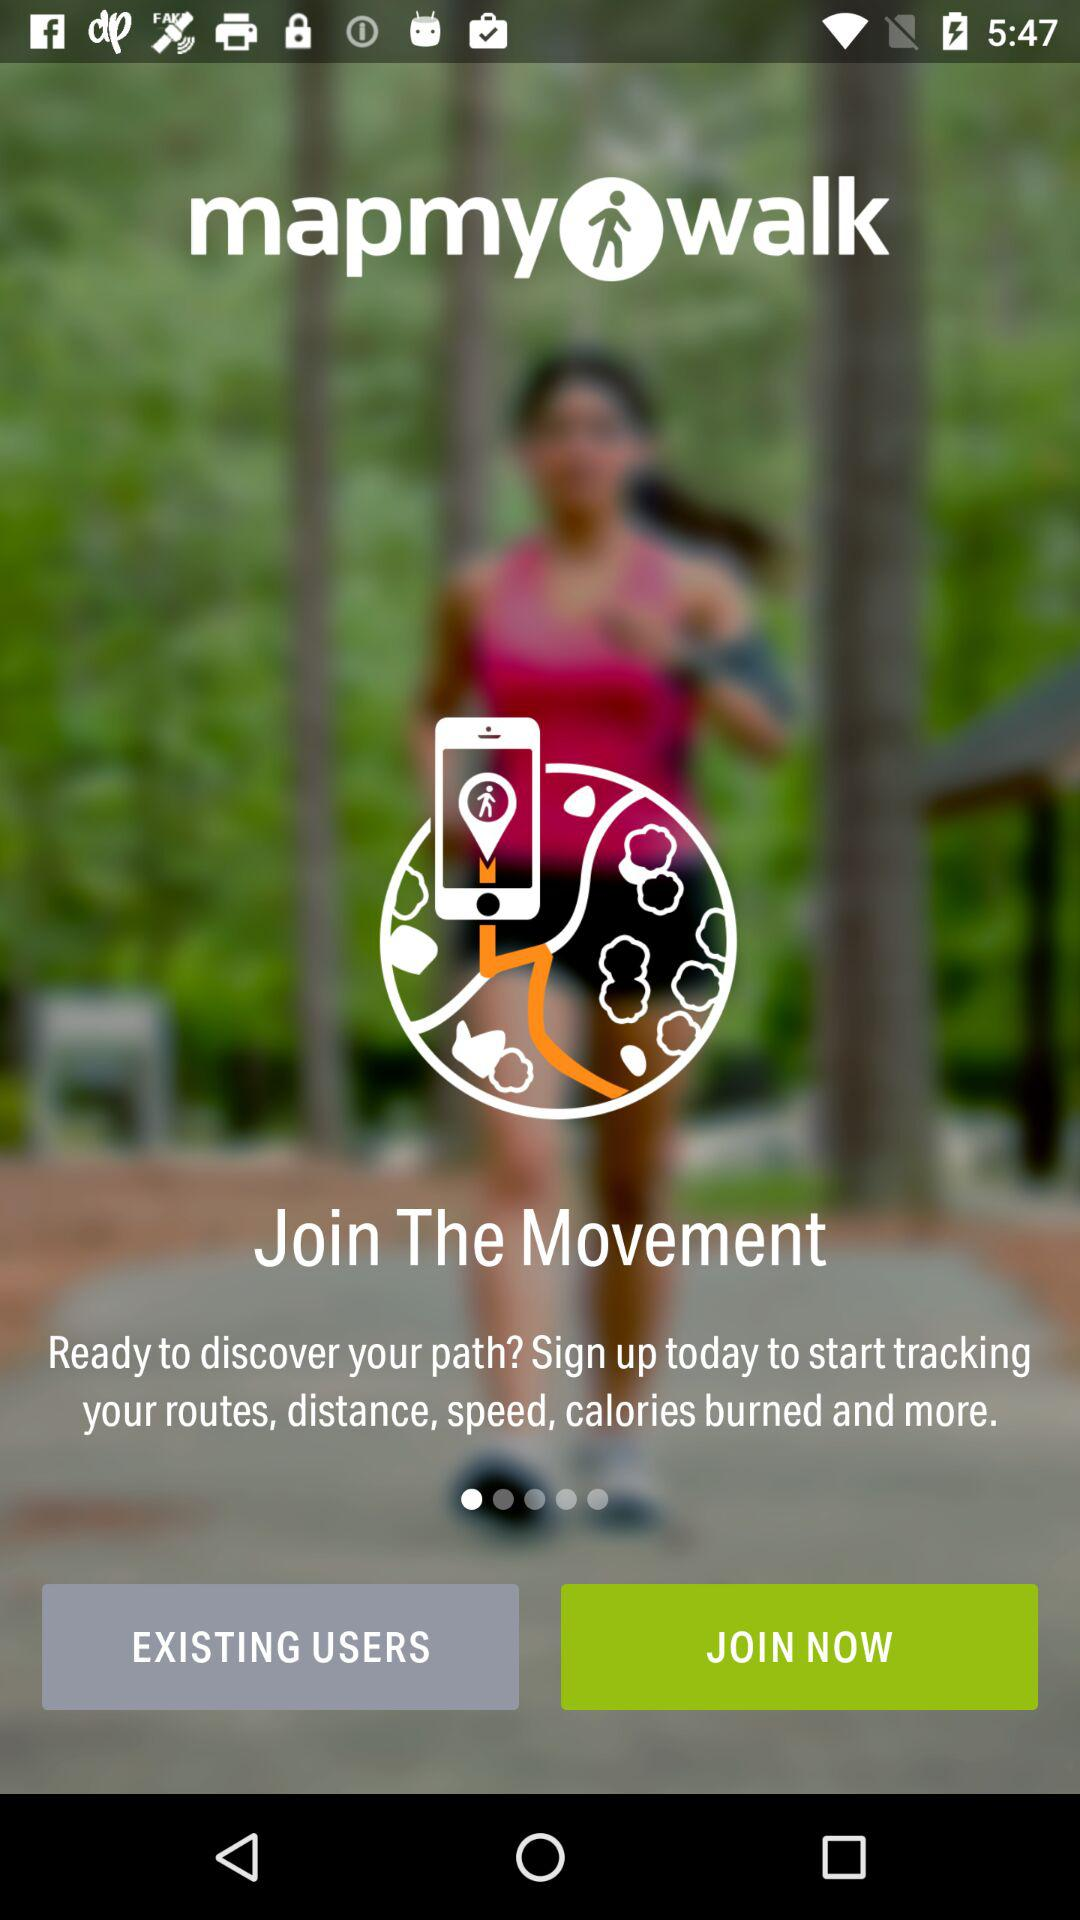What is the name of the application? The name of the application is "mapmy walk". 